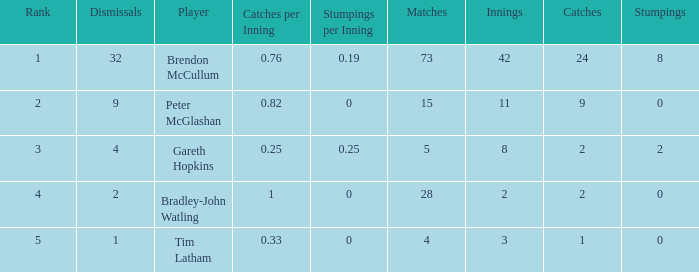How many dismissals did the player Peter McGlashan have? 9.0. Could you parse the entire table? {'header': ['Rank', 'Dismissals', 'Player', 'Catches per Inning', 'Stumpings per Inning', 'Matches', 'Innings', 'Catches', 'Stumpings'], 'rows': [['1', '32', 'Brendon McCullum', '0.76', '0.19', '73', '42', '24', '8'], ['2', '9', 'Peter McGlashan', '0.82', '0', '15', '11', '9', '0'], ['3', '4', 'Gareth Hopkins', '0.25', '0.25', '5', '8', '2', '2'], ['4', '2', 'Bradley-John Watling', '1', '0', '28', '2', '2', '0'], ['5', '1', 'Tim Latham', '0.33', '0', '4', '3', '1', '0']]} 